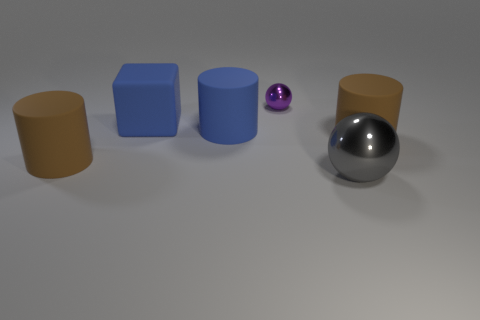There is a big brown object that is right of the metallic ball that is to the left of the big gray sphere; what is it made of?
Ensure brevity in your answer.  Rubber. Is there a rubber object of the same color as the rubber block?
Provide a short and direct response. Yes. How many other small spheres are the same material as the tiny ball?
Provide a short and direct response. 0. There is a purple metal ball on the left side of the large brown rubber object on the right side of the tiny purple sphere; what size is it?
Your response must be concise. Small. The big object that is both right of the tiny metallic ball and behind the big gray shiny sphere is what color?
Your response must be concise. Brown. The thing that is the same color as the block is what size?
Keep it short and to the point. Large. There is a large matte object in front of the matte cylinder on the right side of the tiny object; what shape is it?
Provide a succinct answer. Cylinder. Is the shape of the purple metal object the same as the shiny object in front of the big blue matte cube?
Offer a very short reply. Yes. There is a shiny ball that is the same size as the block; what is its color?
Offer a terse response. Gray. Are there fewer large blue matte blocks that are to the left of the big blue matte cylinder than large objects that are in front of the small purple thing?
Offer a terse response. Yes. 